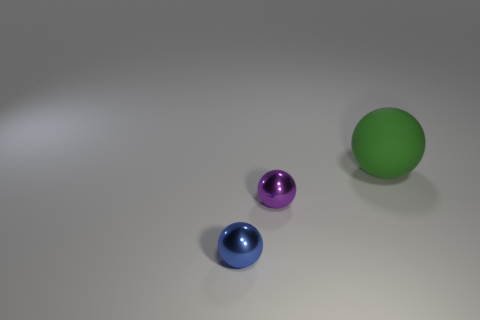Add 3 small green metal cubes. How many objects exist? 6 Subtract all tiny spheres. How many spheres are left? 1 Subtract all green balls. How many balls are left? 2 Add 2 green shiny cylinders. How many green shiny cylinders exist? 2 Subtract 0 gray cylinders. How many objects are left? 3 Subtract all brown balls. Subtract all red blocks. How many balls are left? 3 Subtract all blue cylinders. How many purple balls are left? 1 Subtract all big rubber spheres. Subtract all purple things. How many objects are left? 1 Add 2 green matte balls. How many green matte balls are left? 3 